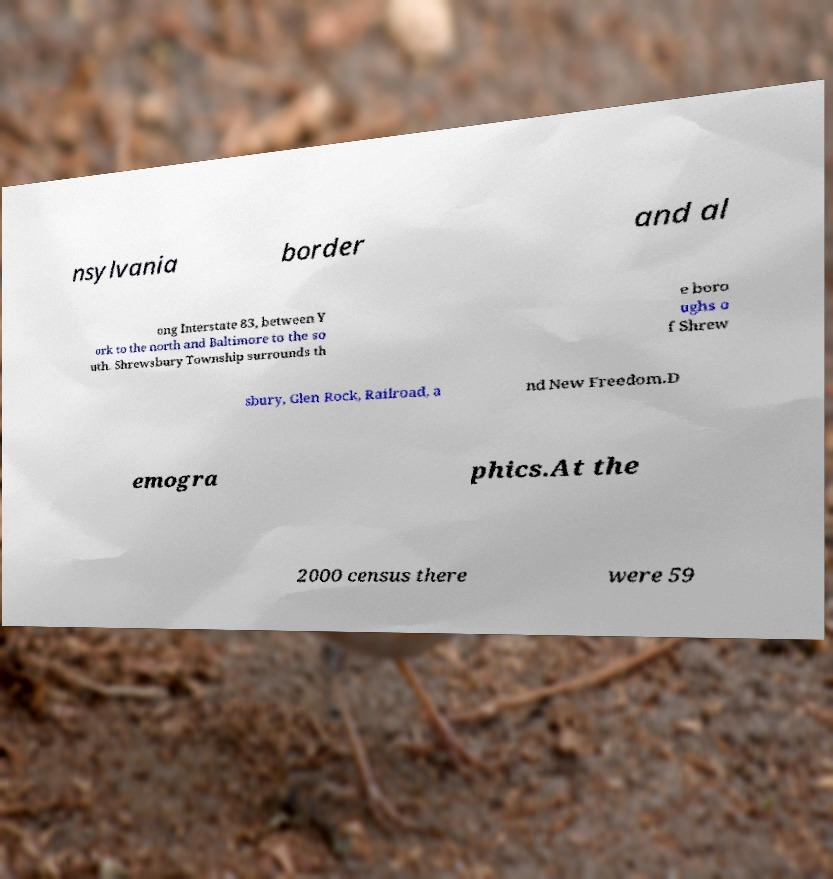I need the written content from this picture converted into text. Can you do that? nsylvania border and al ong Interstate 83, between Y ork to the north and Baltimore to the so uth. Shrewsbury Township surrounds th e boro ughs o f Shrew sbury, Glen Rock, Railroad, a nd New Freedom.D emogra phics.At the 2000 census there were 59 